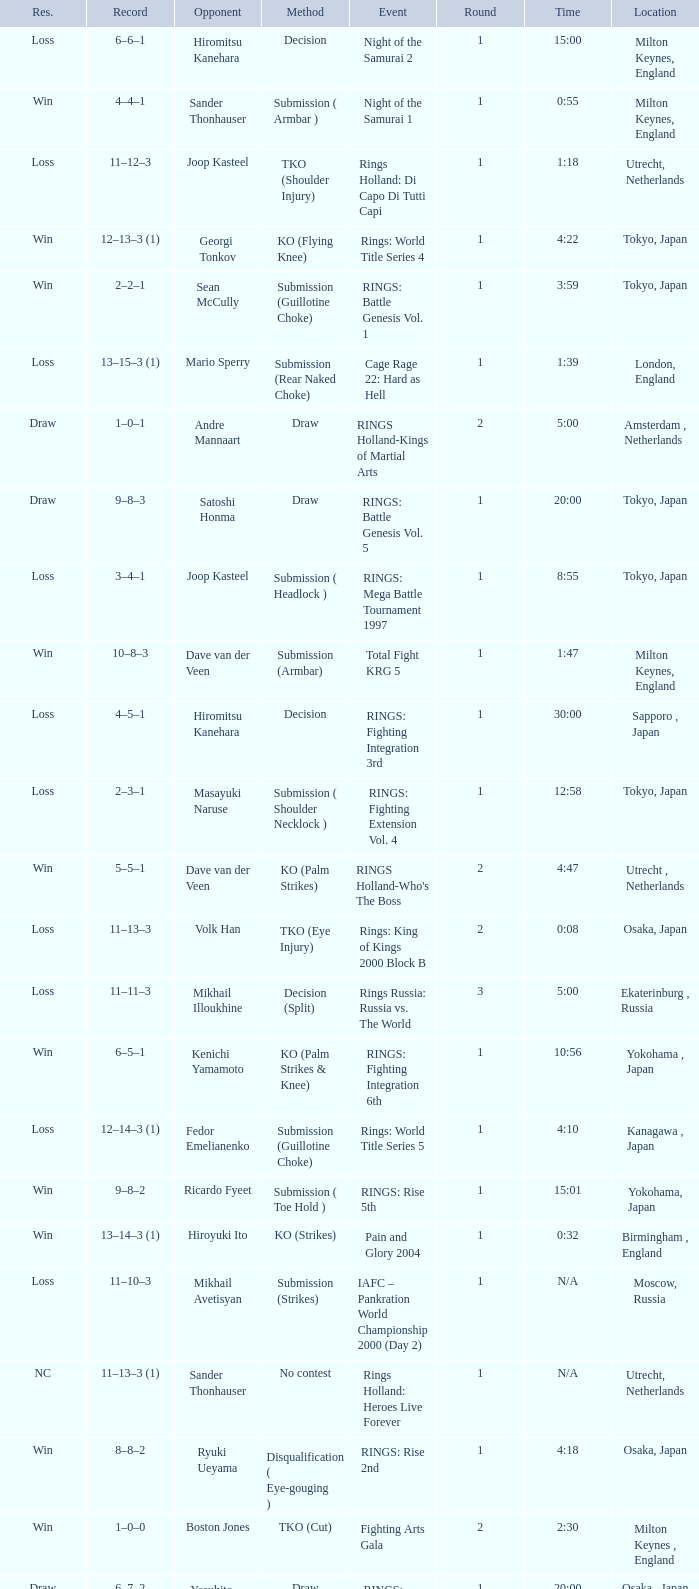What is the time for an opponent of Satoshi Honma? 20:00. 